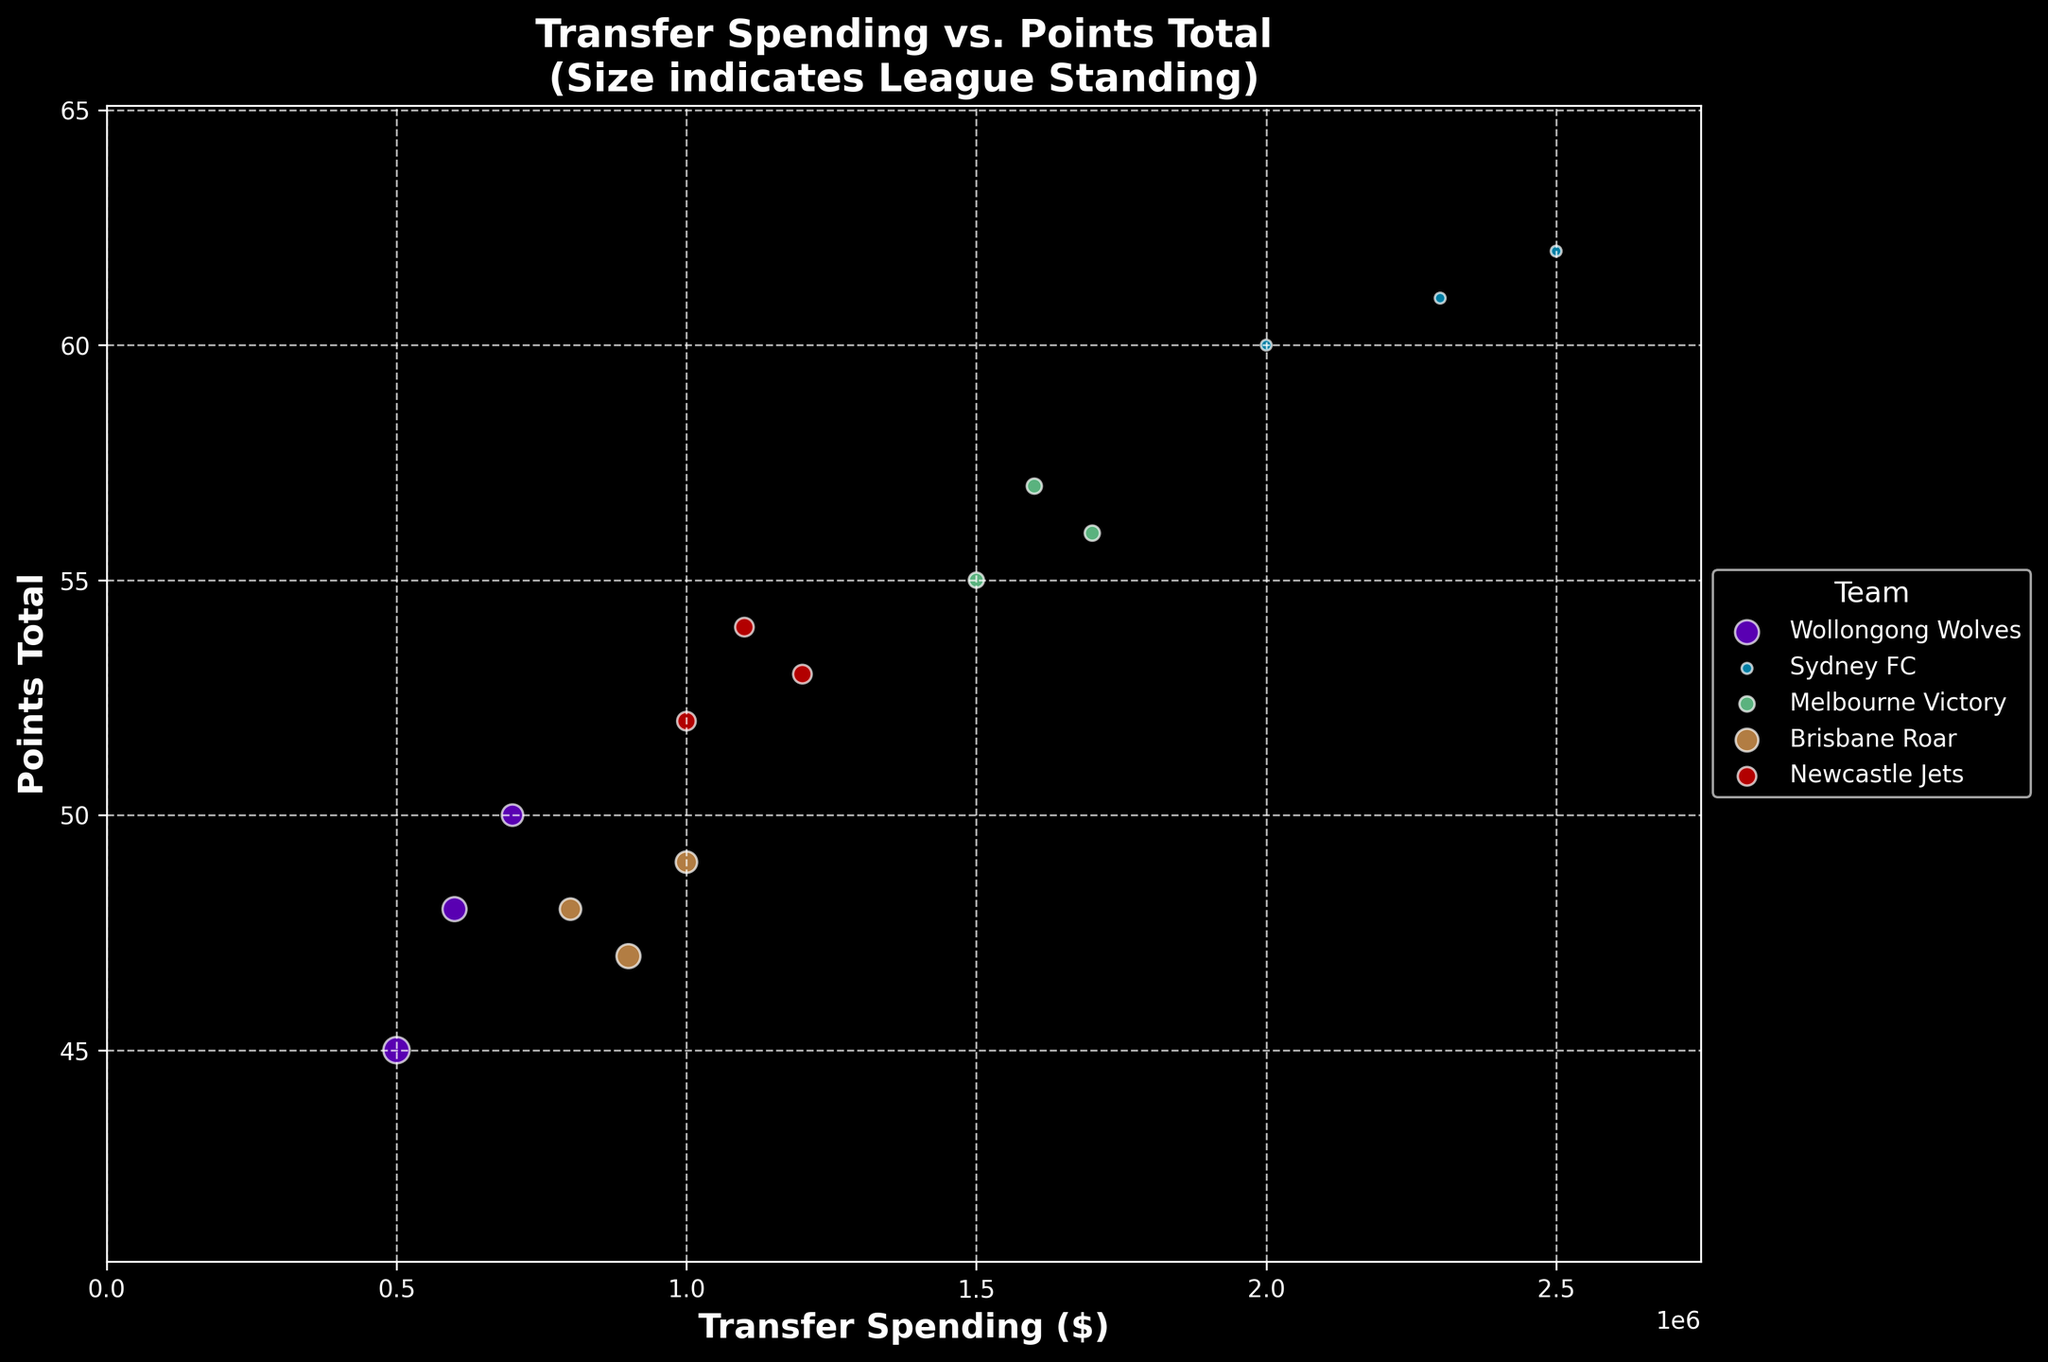What does the title of the chart indicate? The title "Transfer Spending vs. Points Total (Size indicates League Standing)" indicates that the chart shows the relationship between the amount of money teams spend on player transfers and their total points in the season. Additionally, the size of the data points represents the league standing of the team.
Answer: Relationship between transfer spending, points total, and league standing How is the x-axis labeled and what does it represent? The x-axis is labeled "Transfer Spending ($)" and it represents the amount of money teams spent on player transfers.
Answer: Transfer Spending ($) How is the y-axis labeled and what does it represent? The y-axis is labeled "Points Total" and it represents the total number of points each team accumulated over the season.
Answer: Points Total Which team has the highest transfer spending in the 2017-2018 season? From the figure, the data point for Sydney FC in the 2017-2018 season is positioned farthest to the right on the x-axis, indicating the highest transfer spending.
Answer: Sydney FC What is the trend between transfer spending and points total for Wollongong Wolves over the three seasons? By observing the data points for Wollongong Wolves, we can see an upward trend in points total as their transfer spending increases. In the 2017-2018 season, they spent $500,000 and had 45 points, while they spent $700,000 in the next season for 50 points, and $600,000 in the 2019-2020 season for 48 points.
Answer: Positive trend: higher spending generally leads to a better points total How does Sydney FC's points total correlate with their transfer spending over the seasons? Sydney FC shows consistently high transfer spending and points total across all three seasons. Their spending ranges from $2,000,000 to $2,500,000, and their points total remains above 60 in each season, indicating a strong positive correlation.
Answer: Strong positive correlation Which team appears to have the smallest data points, indicating the best league standings? Sydney FC's data points are the smallest, indicating they hold the best league standings each season, consistently placing 1st.
Answer: Sydney FC How does the correlation between transfer spending and league standing appear from the plot? Generally, teams with higher transfer spending tend to have better league standings, as shown by the smaller sized data points for high-spending teams like Sydney FC and Melbourne Victory.
Answer: Higher spending correlates with better league standings Which team shows the most notable improvement in points total with modest transfer spending between the seasons? Wollongong Wolves improved their points total from 45 in 2017-2018 to 50 in 2018-2019 with an increase in transfer spending from $500,000 to $700,000. This shows a notable improvement with a relatively modest increase in spending.
Answer: Wollongong Wolves Considering both transfer spending and points total, which team seems to be the most efficient in spending? Wollongong Wolves seem to be efficient as they consistently achieve moderate to good points total (45-50 points) with relatively low transfer spending compared to other teams like Sydney FC and Melbourne Victory.
Answer: Wollongong Wolves 